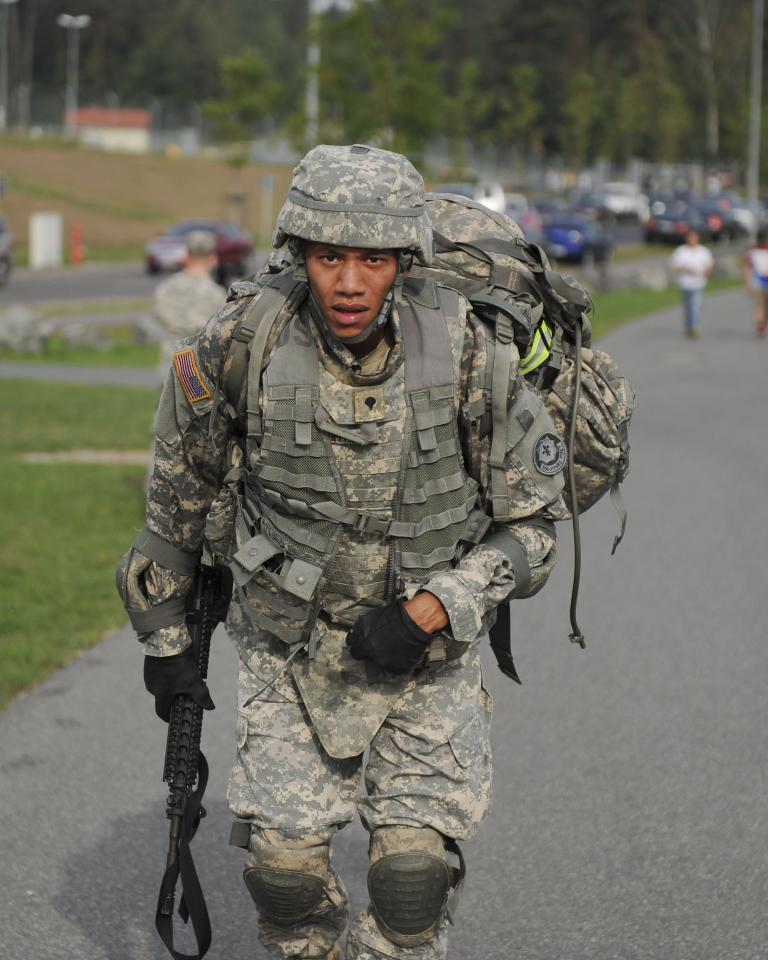In one or two sentences, can you explain what this image depicts? The man in the uniform is standing and he is holding the rifle in his hand. At the bottom, we see the road and the grass. Behind him, we see a man is sitting on the chair and a man in white T-shirt is walking on the road. There are cars in the background. There are trees, buildings and street lights in the background. This picture is blurred in the background. 